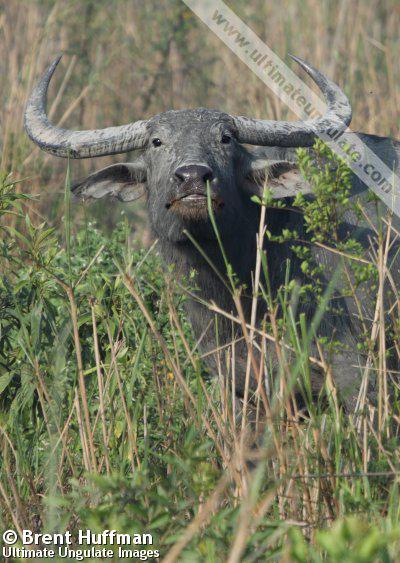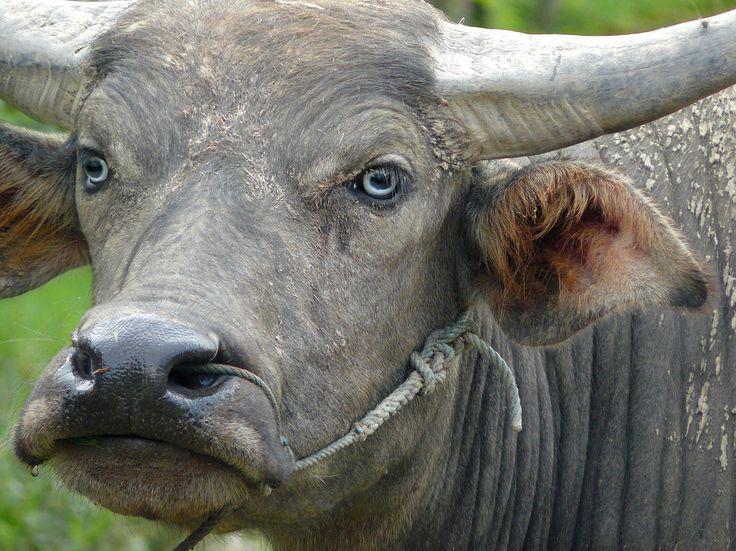The first image is the image on the left, the second image is the image on the right. Given the left and right images, does the statement "There are three animals." hold true? Answer yes or no. No. 